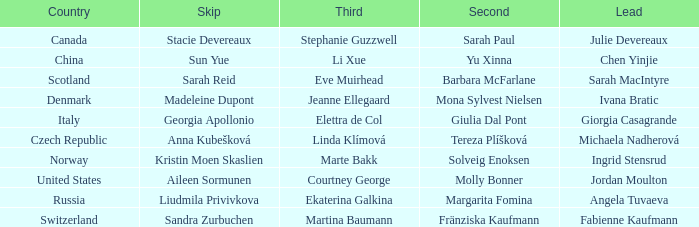What is the second that has jordan moulton as the lead? Molly Bonner. 